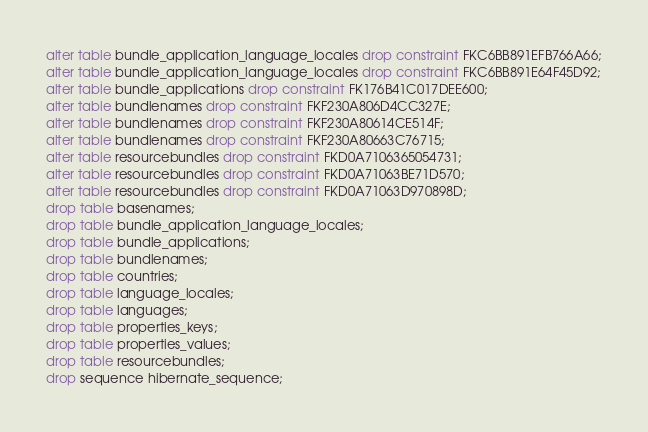Convert code to text. <code><loc_0><loc_0><loc_500><loc_500><_SQL_>alter table bundle_application_language_locales drop constraint FKC6BB891EFB766A66;
alter table bundle_application_language_locales drop constraint FKC6BB891E64F45D92;
alter table bundle_applications drop constraint FK176B41C017DEE600;
alter table bundlenames drop constraint FKF230A806D4CC327E;
alter table bundlenames drop constraint FKF230A80614CE514F;
alter table bundlenames drop constraint FKF230A80663C76715;
alter table resourcebundles drop constraint FKD0A7106365054731;
alter table resourcebundles drop constraint FKD0A71063BE71D570;
alter table resourcebundles drop constraint FKD0A71063D970898D;
drop table basenames;
drop table bundle_application_language_locales;
drop table bundle_applications;
drop table bundlenames;
drop table countries;
drop table language_locales;
drop table languages;
drop table properties_keys;
drop table properties_values;
drop table resourcebundles;
drop sequence hibernate_sequence;
</code> 